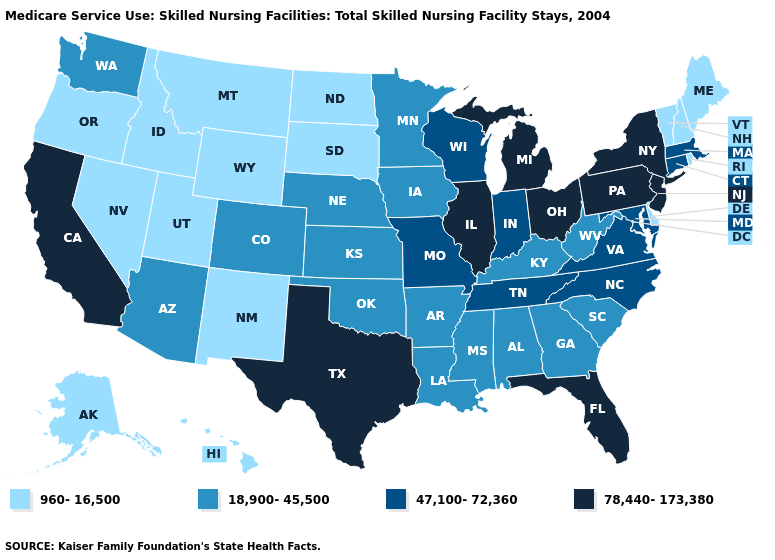What is the lowest value in the USA?
Quick response, please. 960-16,500. Name the states that have a value in the range 78,440-173,380?
Concise answer only. California, Florida, Illinois, Michigan, New Jersey, New York, Ohio, Pennsylvania, Texas. Does the map have missing data?
Concise answer only. No. Does the first symbol in the legend represent the smallest category?
Give a very brief answer. Yes. Does Alabama have the highest value in the USA?
Write a very short answer. No. What is the lowest value in the Northeast?
Give a very brief answer. 960-16,500. Does New Hampshire have the highest value in the Northeast?
Short answer required. No. Does Texas have the highest value in the USA?
Concise answer only. Yes. Does California have the highest value in the West?
Answer briefly. Yes. Name the states that have a value in the range 960-16,500?
Quick response, please. Alaska, Delaware, Hawaii, Idaho, Maine, Montana, Nevada, New Hampshire, New Mexico, North Dakota, Oregon, Rhode Island, South Dakota, Utah, Vermont, Wyoming. Does Arizona have the highest value in the West?
Keep it brief. No. Is the legend a continuous bar?
Concise answer only. No. Is the legend a continuous bar?
Answer briefly. No. Name the states that have a value in the range 78,440-173,380?
Answer briefly. California, Florida, Illinois, Michigan, New Jersey, New York, Ohio, Pennsylvania, Texas. What is the lowest value in the South?
Be succinct. 960-16,500. 